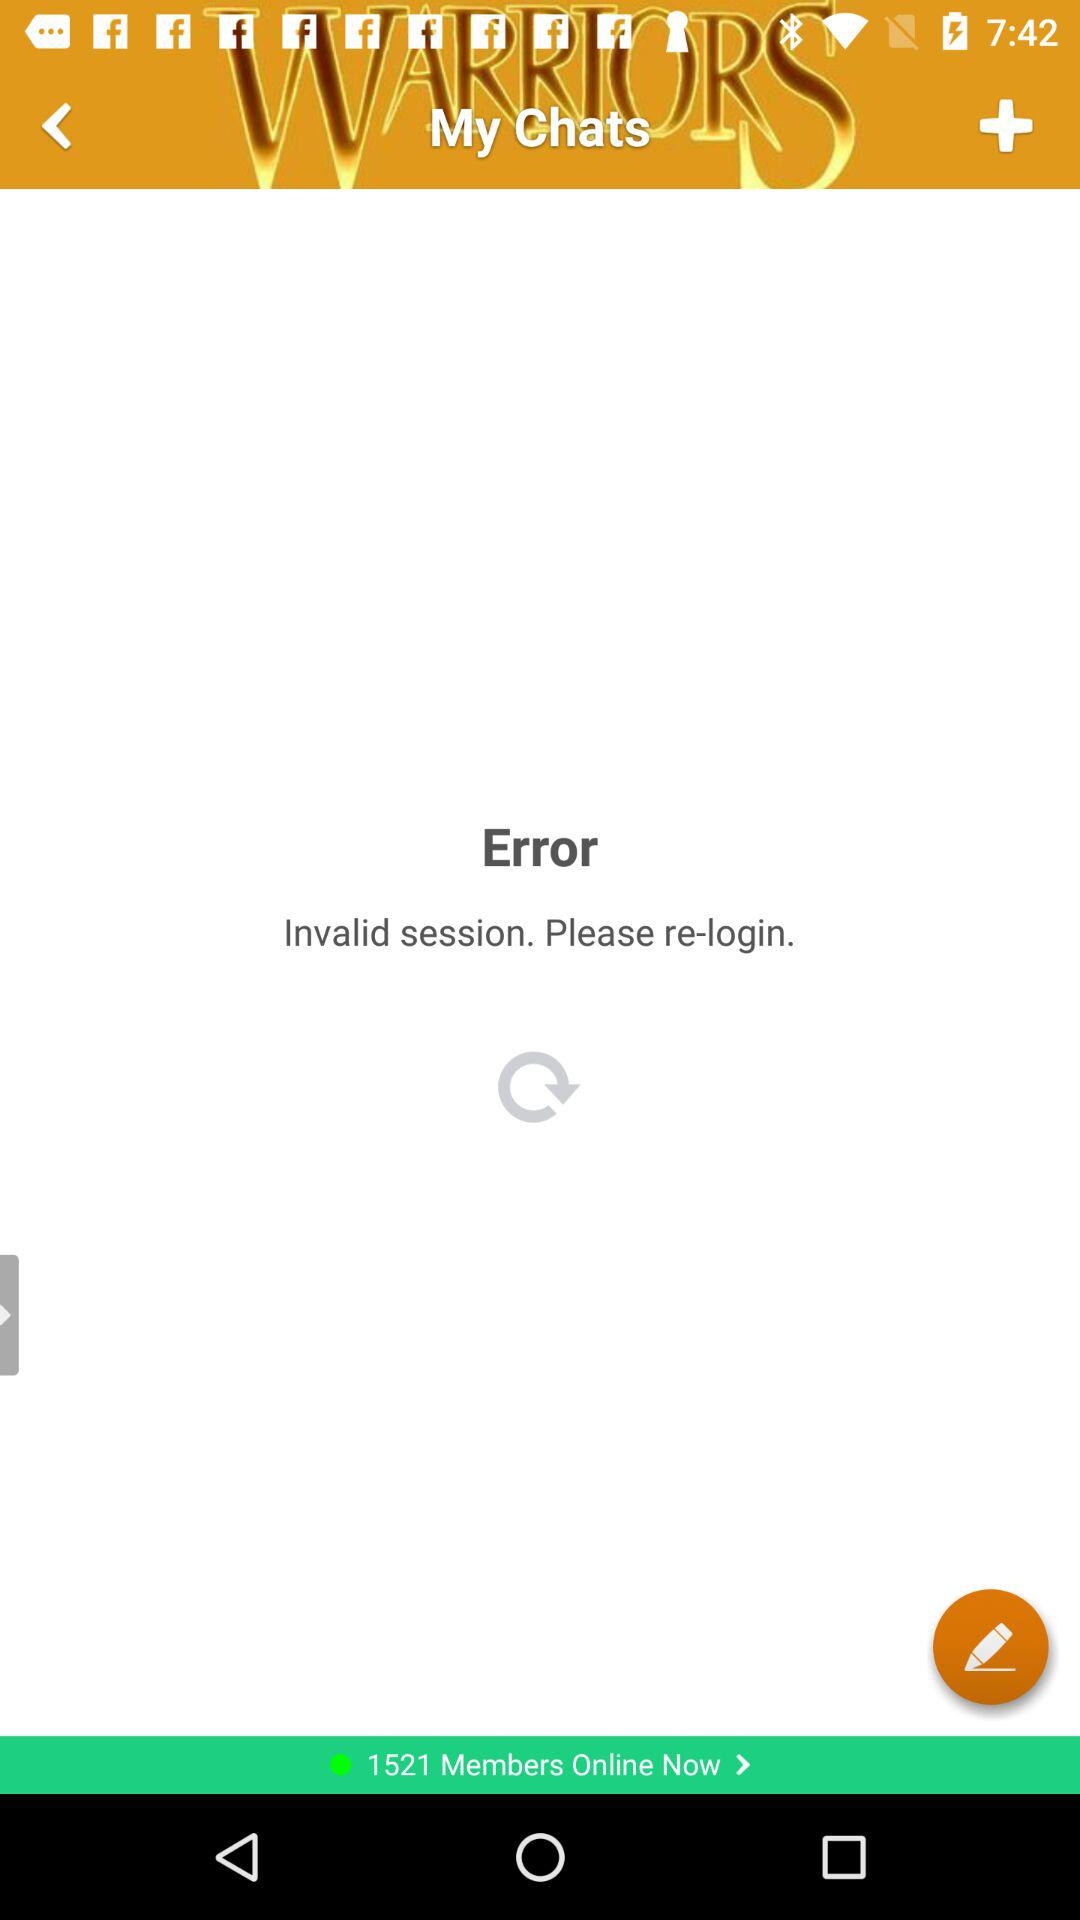When was the last chat posted?
When the provided information is insufficient, respond with <no answer>. <no answer> 